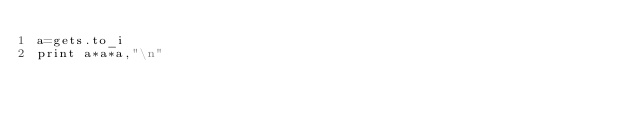<code> <loc_0><loc_0><loc_500><loc_500><_Ruby_>a=gets.to_i
print a*a*a,"\n"</code> 